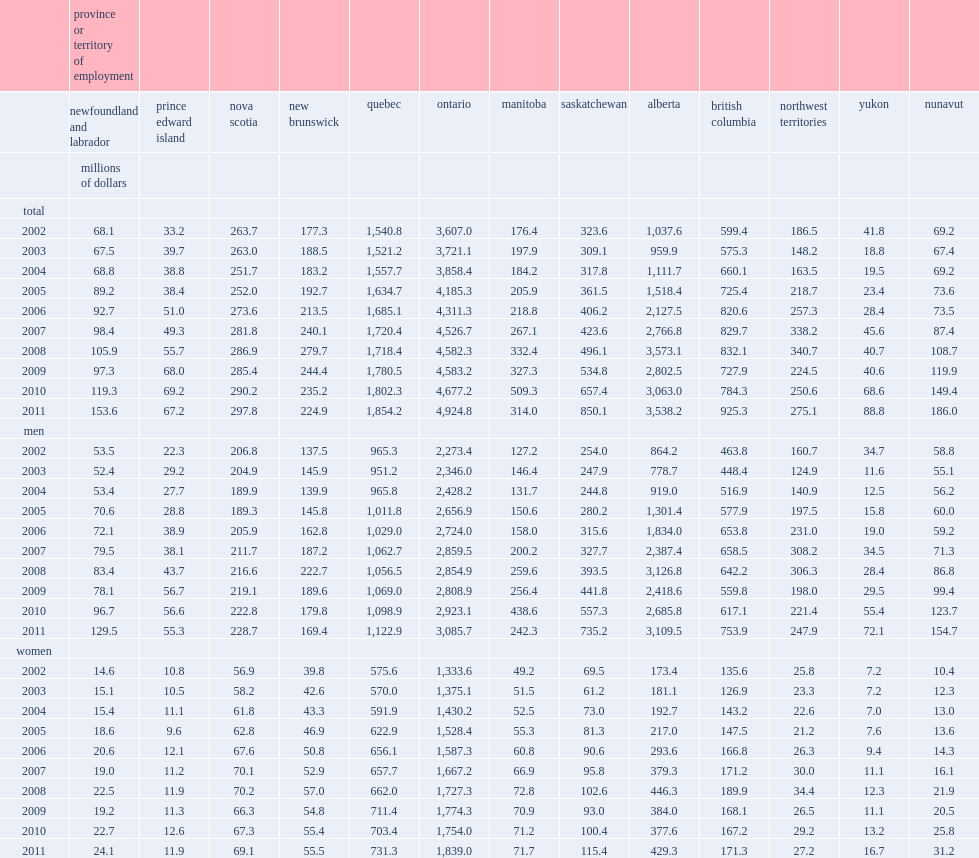How much do interprovincial employees receive in wages and salaries in 2011? 13700.0. 